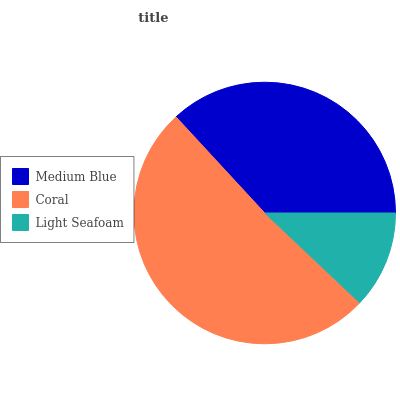Is Light Seafoam the minimum?
Answer yes or no. Yes. Is Coral the maximum?
Answer yes or no. Yes. Is Coral the minimum?
Answer yes or no. No. Is Light Seafoam the maximum?
Answer yes or no. No. Is Coral greater than Light Seafoam?
Answer yes or no. Yes. Is Light Seafoam less than Coral?
Answer yes or no. Yes. Is Light Seafoam greater than Coral?
Answer yes or no. No. Is Coral less than Light Seafoam?
Answer yes or no. No. Is Medium Blue the high median?
Answer yes or no. Yes. Is Medium Blue the low median?
Answer yes or no. Yes. Is Coral the high median?
Answer yes or no. No. Is Coral the low median?
Answer yes or no. No. 